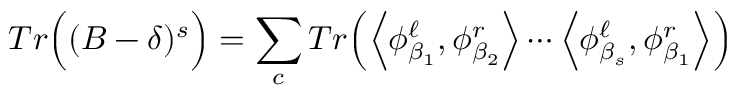Convert formula to latex. <formula><loc_0><loc_0><loc_500><loc_500>T r \left ( ( B - \delta ) ^ { s } \right ) = \sum _ { c } T r \left ( \Big < \phi _ { \beta _ { 1 } } ^ { \ell } , \phi _ { \beta _ { 2 } } ^ { r } \Big > \cdots \Big < \phi _ { \beta _ { s } } ^ { \ell } , \phi _ { \beta _ { 1 } } ^ { r } \Big > \right )</formula> 